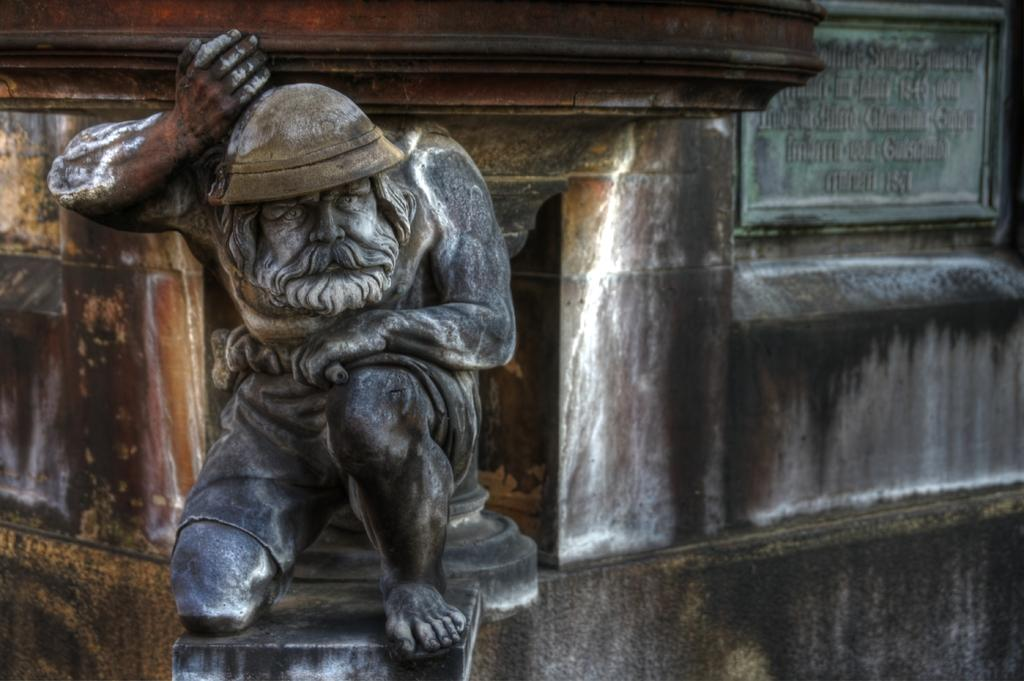What is the main subject of the image? The main subject of the image is a stone statue of a man. Is there any additional information about the statue provided in the image? Yes, there is a stone naming plate behind the statue. What can be seen in the background of the image? There is a huge rock pillar behind the statue. What type of paper is the statue holding in the image? There is no paper present in the image; the statue is made of stone and does not hold any objects. 